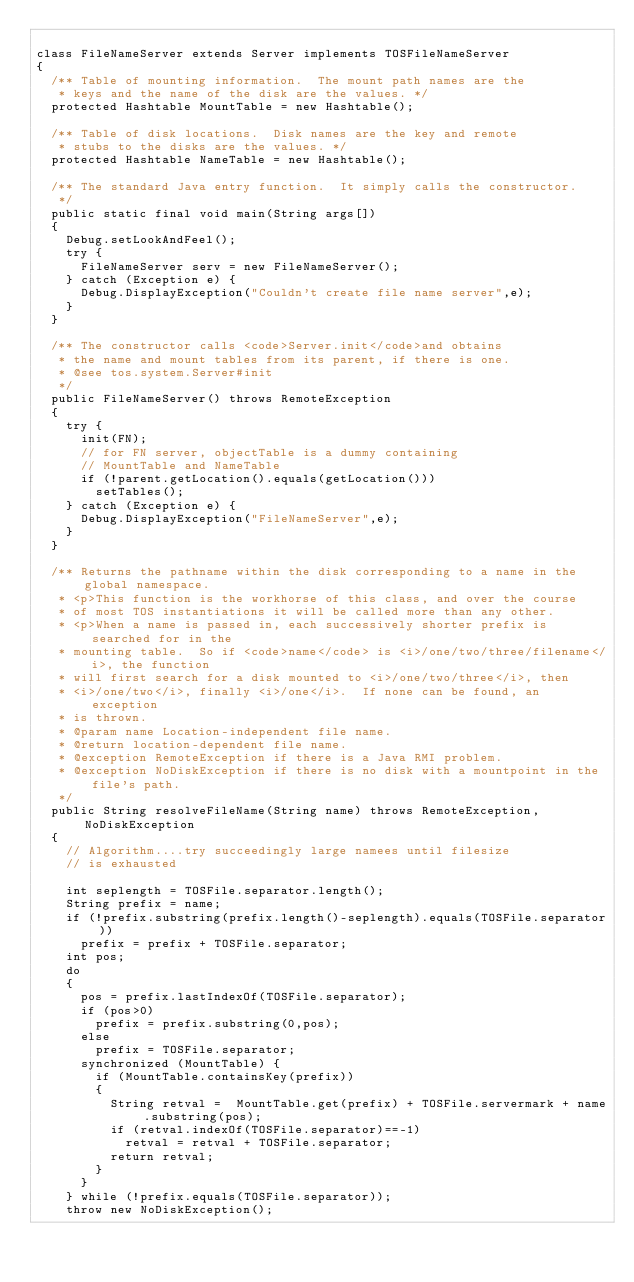Convert code to text. <code><loc_0><loc_0><loc_500><loc_500><_Java_>
class FileNameServer extends Server implements TOSFileNameServer
{
	/** Table of mounting information.  The mount path names are the 
	 * keys and the name of the disk are the values. */
	protected Hashtable MountTable = new Hashtable();
	
	/** Table of disk locations.  Disk names are the key and remote
	 * stubs to the disks are the values. */
	protected Hashtable NameTable = new Hashtable();

	/** The standard Java entry function.  It simply calls the constructor.
	 */
	public static final void main(String args[])
	{
		Debug.setLookAndFeel();
		try {
			FileNameServer serv = new FileNameServer();
		} catch (Exception e) {
			Debug.DisplayException("Couldn't create file name server",e);
		}
	}

	/** The constructor calls <code>Server.init</code>and obtains 
	 * the name and mount tables from its parent, if there is one.
	 * @see tos.system.Server#init
	 */
	public FileNameServer() throws RemoteException
	{
		try {
			init(FN);
			// for FN server, objectTable is a dummy containing 
			// MountTable and NameTable
			if (!parent.getLocation().equals(getLocation()))
				setTables();
		} catch (Exception e) {
			Debug.DisplayException("FileNameServer",e);
		}
	}

	/** Returns the pathname within the disk corresponding to a name in the global namespace.
	 * <p>This function is the workhorse of this class, and over the course
	 * of most TOS instantiations it will be called more than any other.
	 * <p>When a name is passed in, each successively shorter prefix is searched for in the 
	 * mounting table.  So if <code>name</code> is <i>/one/two/three/filename</i>, the function
	 * will first search for a disk mounted to <i>/one/two/three</i>, then
	 * <i>/one/two</i>, finally <i>/one</i>.  If none can be found, an exception
	 * is thrown.
	 * @param name Location-independent file name.
	 * @return location-dependent file name.
	 * @exception RemoteException if there is a Java RMI problem.
	 * @exception NoDiskException if there is no disk with a mountpoint in the file's path.
	 */
	public String resolveFileName(String name) throws RemoteException, NoDiskException
	{
		// Algorithm....try succeedingly large namees until filesize
		// is exhausted
		
		int seplength = TOSFile.separator.length();
		String prefix = name;
		if (!prefix.substring(prefix.length()-seplength).equals(TOSFile.separator))
			prefix = prefix + TOSFile.separator;
		int pos;
		do
		{
			pos = prefix.lastIndexOf(TOSFile.separator);
			if (pos>0)
				prefix = prefix.substring(0,pos);
			else
				prefix = TOSFile.separator;
			synchronized (MountTable) {
				if (MountTable.containsKey(prefix))
				{
					String retval =  MountTable.get(prefix) + TOSFile.servermark + name.substring(pos);
					if (retval.indexOf(TOSFile.separator)==-1)
						retval = retval + TOSFile.separator;
					return retval;
				}
			}
		} while (!prefix.equals(TOSFile.separator));
		throw new NoDiskException();</code> 